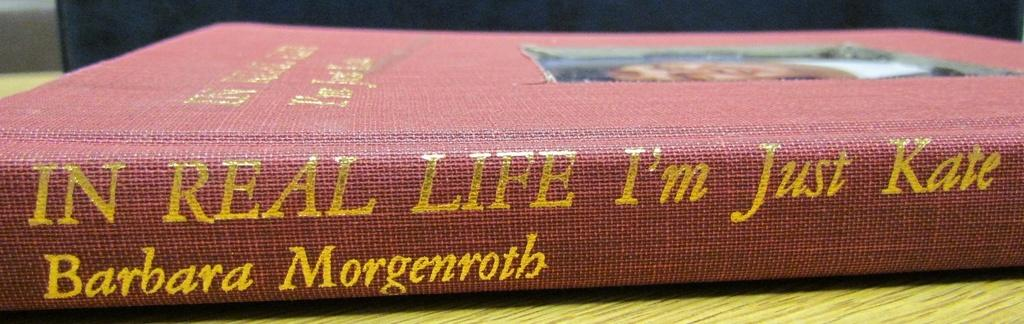<image>
Provide a brief description of the given image. The spine of the book "In Real Life" by Barbara Morgenroth. 